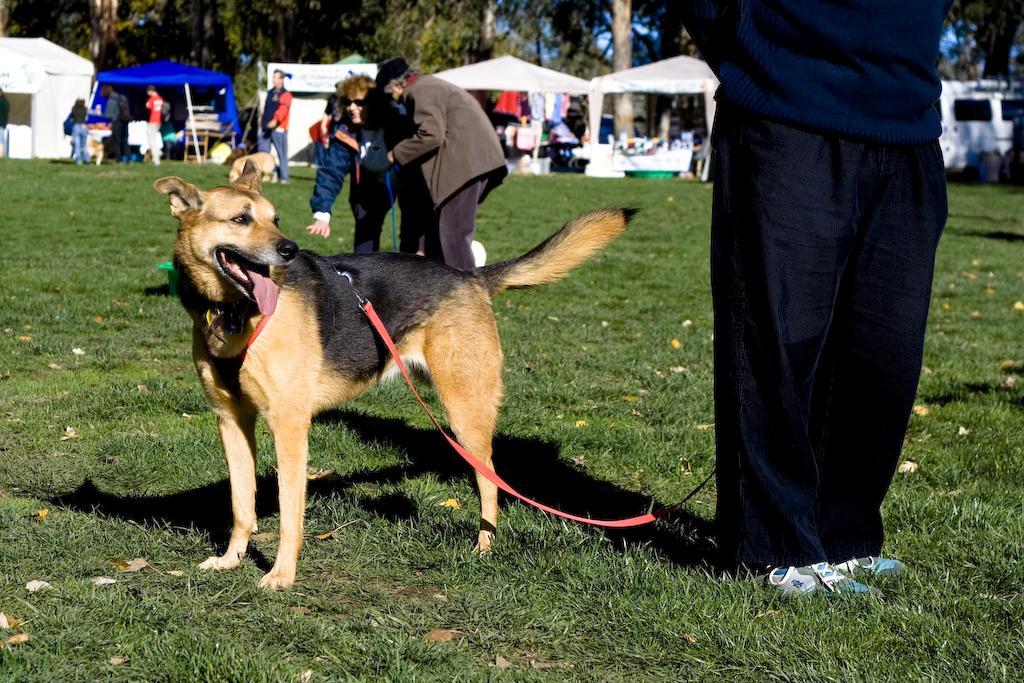How would you summarize this image in a sentence or two? In this picture we can see people on the ground,here we can see dogs and in the background we can see tents,trees. 